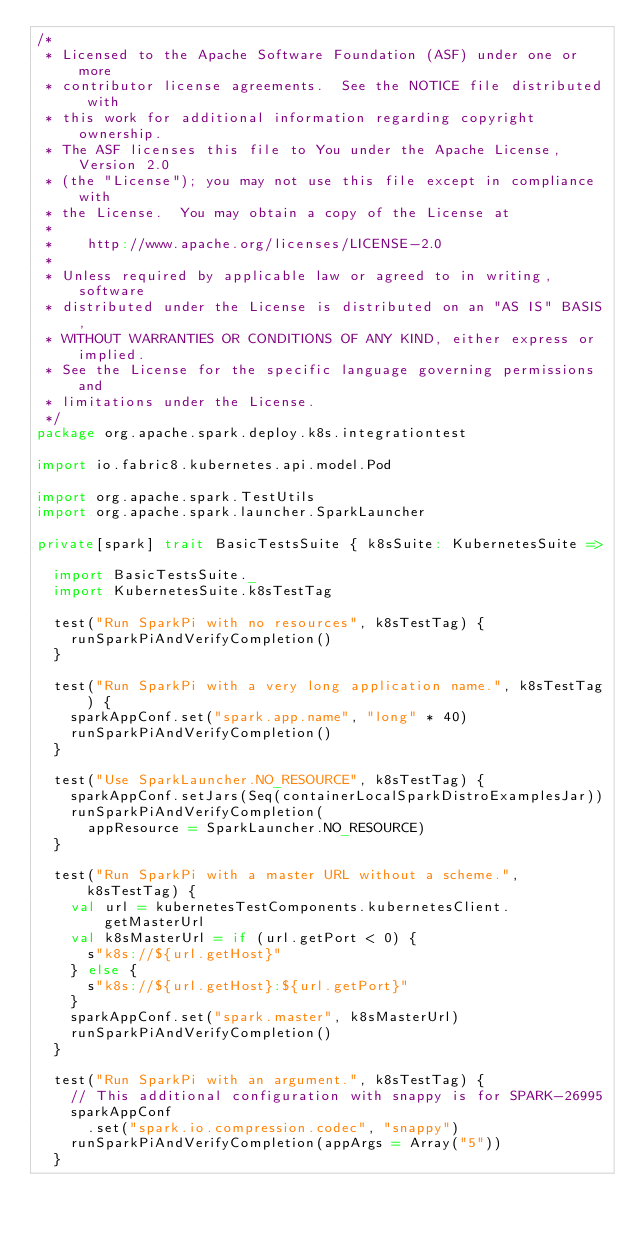<code> <loc_0><loc_0><loc_500><loc_500><_Scala_>/*
 * Licensed to the Apache Software Foundation (ASF) under one or more
 * contributor license agreements.  See the NOTICE file distributed with
 * this work for additional information regarding copyright ownership.
 * The ASF licenses this file to You under the Apache License, Version 2.0
 * (the "License"); you may not use this file except in compliance with
 * the License.  You may obtain a copy of the License at
 *
 *    http://www.apache.org/licenses/LICENSE-2.0
 *
 * Unless required by applicable law or agreed to in writing, software
 * distributed under the License is distributed on an "AS IS" BASIS,
 * WITHOUT WARRANTIES OR CONDITIONS OF ANY KIND, either express or implied.
 * See the License for the specific language governing permissions and
 * limitations under the License.
 */
package org.apache.spark.deploy.k8s.integrationtest

import io.fabric8.kubernetes.api.model.Pod

import org.apache.spark.TestUtils
import org.apache.spark.launcher.SparkLauncher

private[spark] trait BasicTestsSuite { k8sSuite: KubernetesSuite =>

  import BasicTestsSuite._
  import KubernetesSuite.k8sTestTag

  test("Run SparkPi with no resources", k8sTestTag) {
    runSparkPiAndVerifyCompletion()
  }

  test("Run SparkPi with a very long application name.", k8sTestTag) {
    sparkAppConf.set("spark.app.name", "long" * 40)
    runSparkPiAndVerifyCompletion()
  }

  test("Use SparkLauncher.NO_RESOURCE", k8sTestTag) {
    sparkAppConf.setJars(Seq(containerLocalSparkDistroExamplesJar))
    runSparkPiAndVerifyCompletion(
      appResource = SparkLauncher.NO_RESOURCE)
  }

  test("Run SparkPi with a master URL without a scheme.", k8sTestTag) {
    val url = kubernetesTestComponents.kubernetesClient.getMasterUrl
    val k8sMasterUrl = if (url.getPort < 0) {
      s"k8s://${url.getHost}"
    } else {
      s"k8s://${url.getHost}:${url.getPort}"
    }
    sparkAppConf.set("spark.master", k8sMasterUrl)
    runSparkPiAndVerifyCompletion()
  }

  test("Run SparkPi with an argument.", k8sTestTag) {
    // This additional configuration with snappy is for SPARK-26995
    sparkAppConf
      .set("spark.io.compression.codec", "snappy")
    runSparkPiAndVerifyCompletion(appArgs = Array("5"))
  }
</code> 